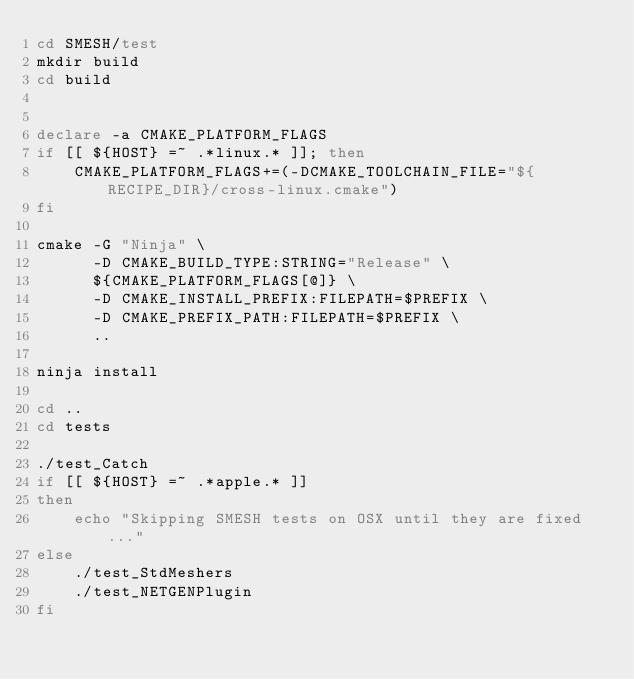<code> <loc_0><loc_0><loc_500><loc_500><_Bash_>cd SMESH/test
mkdir build
cd build


declare -a CMAKE_PLATFORM_FLAGS
if [[ ${HOST} =~ .*linux.* ]]; then
    CMAKE_PLATFORM_FLAGS+=(-DCMAKE_TOOLCHAIN_FILE="${RECIPE_DIR}/cross-linux.cmake")
fi

cmake -G "Ninja" \
      -D CMAKE_BUILD_TYPE:STRING="Release" \
      ${CMAKE_PLATFORM_FLAGS[@]} \
      -D CMAKE_INSTALL_PREFIX:FILEPATH=$PREFIX \
      -D CMAKE_PREFIX_PATH:FILEPATH=$PREFIX \
      ..

ninja install

cd ..
cd tests

./test_Catch
if [[ ${HOST} =~ .*apple.* ]]
then
    echo "Skipping SMESH tests on OSX until they are fixed..."
else
    ./test_StdMeshers
    ./test_NETGENPlugin
fi </code> 